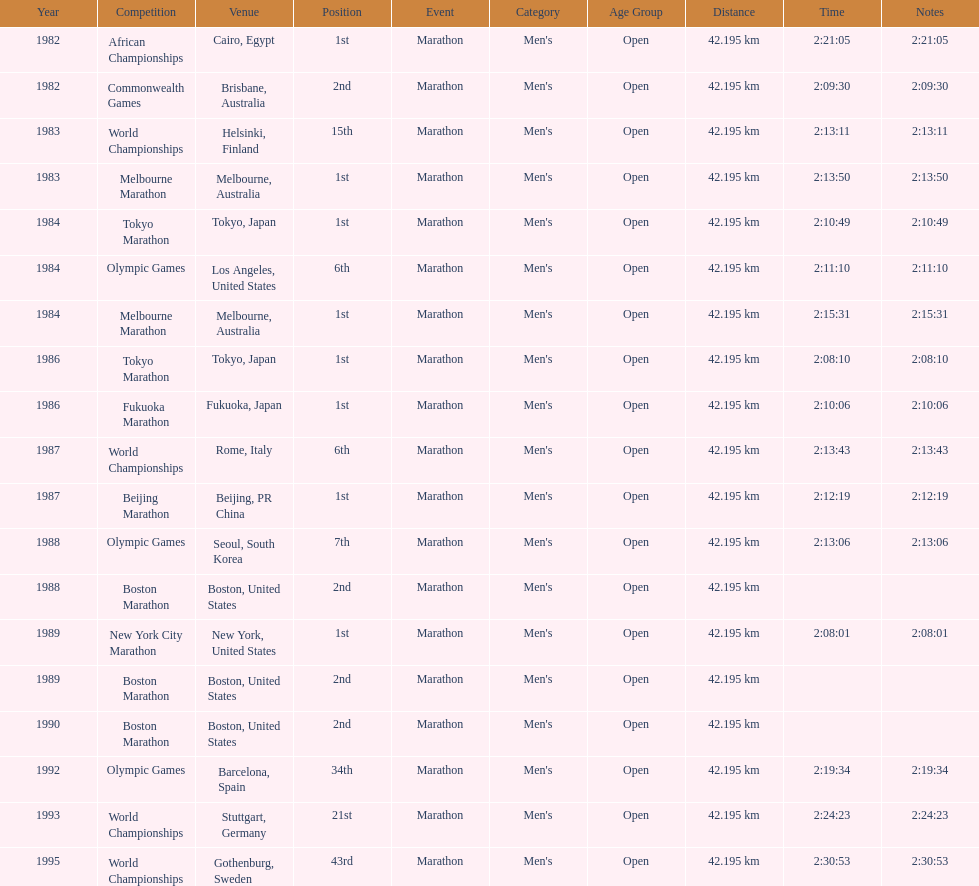How often was the venue found in the united states? 5. 